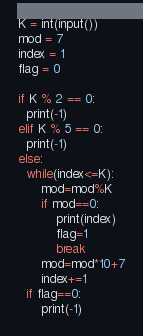Convert code to text. <code><loc_0><loc_0><loc_500><loc_500><_Python_>K = int(input())
mod = 7
index = 1
flag = 0

if K % 2 == 0:
  print(-1)
elif K % 5 == 0:
  print(-1)
else:  
  while(index<=K):
      mod=mod%K
      if mod==0:
          print(index)
          flag=1
          break
      mod=mod*10+7
      index+=1
  if flag==0:
      print(-1)</code> 